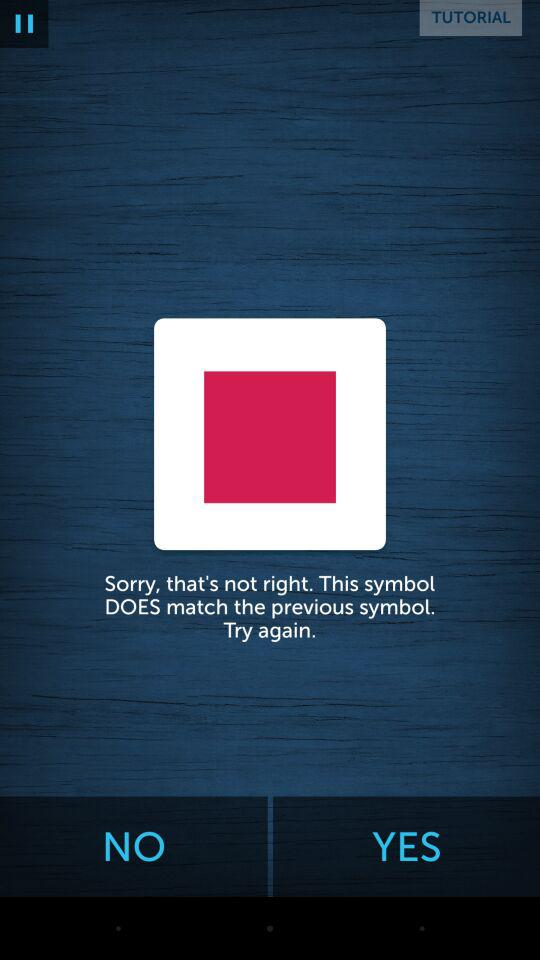Through what app can we continue? You can continue with "Facebook". 